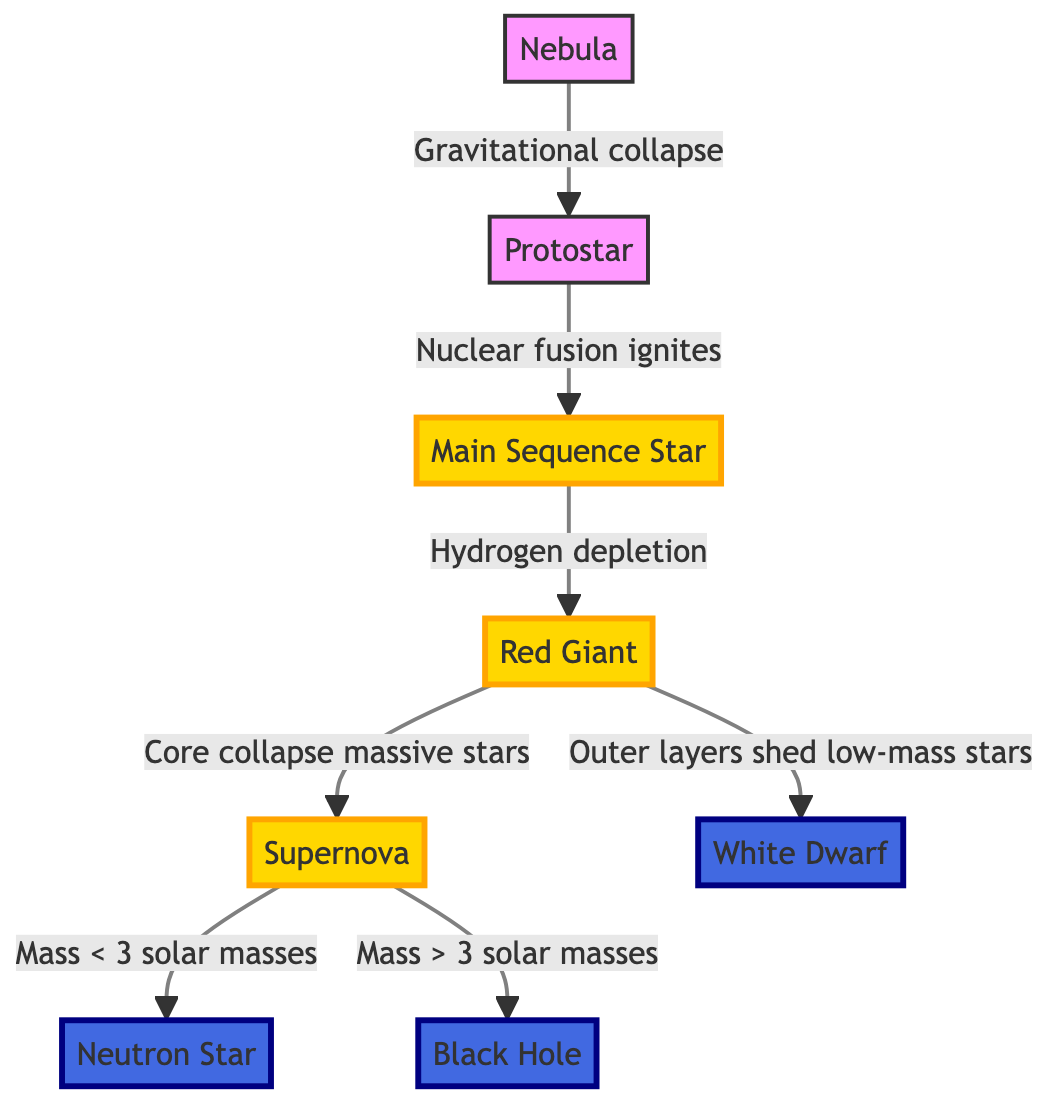What is the first stage of a star's lifecycle? The diagram shows that the first stage in the lifecycle of a star is represented by the node labeled "Nebula". It is the starting point from which the process begins.
Answer: Nebula What do protostars transform into? According to the diagram, the node "Protostar" points to the node "Main Sequence Star", indicating that protostars evolve into main sequence stars as nuclear fusion ignites.
Answer: Main Sequence Star What happens after a main sequence star depletes hydrogen? The diagram indicates that when a main sequence star depletes hydrogen, it transitions into a "Red Giant" as shown by the arrow leading to this node.
Answer: Red Giant What results from a supernova of a star with mass greater than 3 solar masses? The diagram illustrates that a supernova from a star with mass greater than 3 solar masses leads to the formation of a "Black Hole", as shown by the arrow directed towards this node.
Answer: Black Hole How many final states are there for stars according to this diagram? Counting the end nodes in the diagram, we see three final states: "Neutron Star", "Black Hole", and "White Dwarf". This means there are a total of three different outcomes for a star's lifecycle.
Answer: 3 What leads to the creation of a white dwarf? The diagram shows that a red giant sheds its outer layers to create a "White Dwarf". This is indicated by the arrow leading from "Red Giant" to "White Dwarf".
Answer: Outer layers shed low-mass stars What is the fate of low-mass stars after the red giant phase? The diagram specifies that low-mass stars will end their lifecycle by shedding their outer layers as indicated by the arrow from "Red Giant" to "White Dwarf". It implies that shedding outer layers is the process leading to this final state.
Answer: White Dwarf What is a common concluding phase for stars after a supernova? The diagram shows that after a supernova, one possible conclusion for stars (specifically those with less than 3 solar masses) is the development of a "Neutron Star". Thus, this phase is a potential outcome depending on the star’s initial mass.
Answer: Neutron Star Which part of the diagram represents gravitational collapse? The diagram describes the process of "Gravitational collapse" that leads from the "Nebula" to the "Protostar". It shows the connection from one node to the next, indicating this process of formation.
Answer: Gravitational collapse 